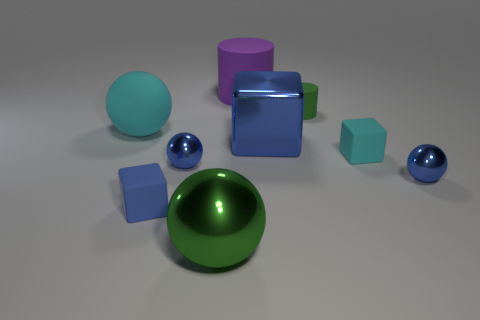Subtract 1 spheres. How many spheres are left? 3 Add 1 small objects. How many objects exist? 10 Subtract all blocks. How many objects are left? 6 Add 8 large blue metal blocks. How many large blue metal blocks exist? 9 Subtract 0 yellow balls. How many objects are left? 9 Subtract all balls. Subtract all tiny yellow shiny spheres. How many objects are left? 5 Add 4 purple cylinders. How many purple cylinders are left? 5 